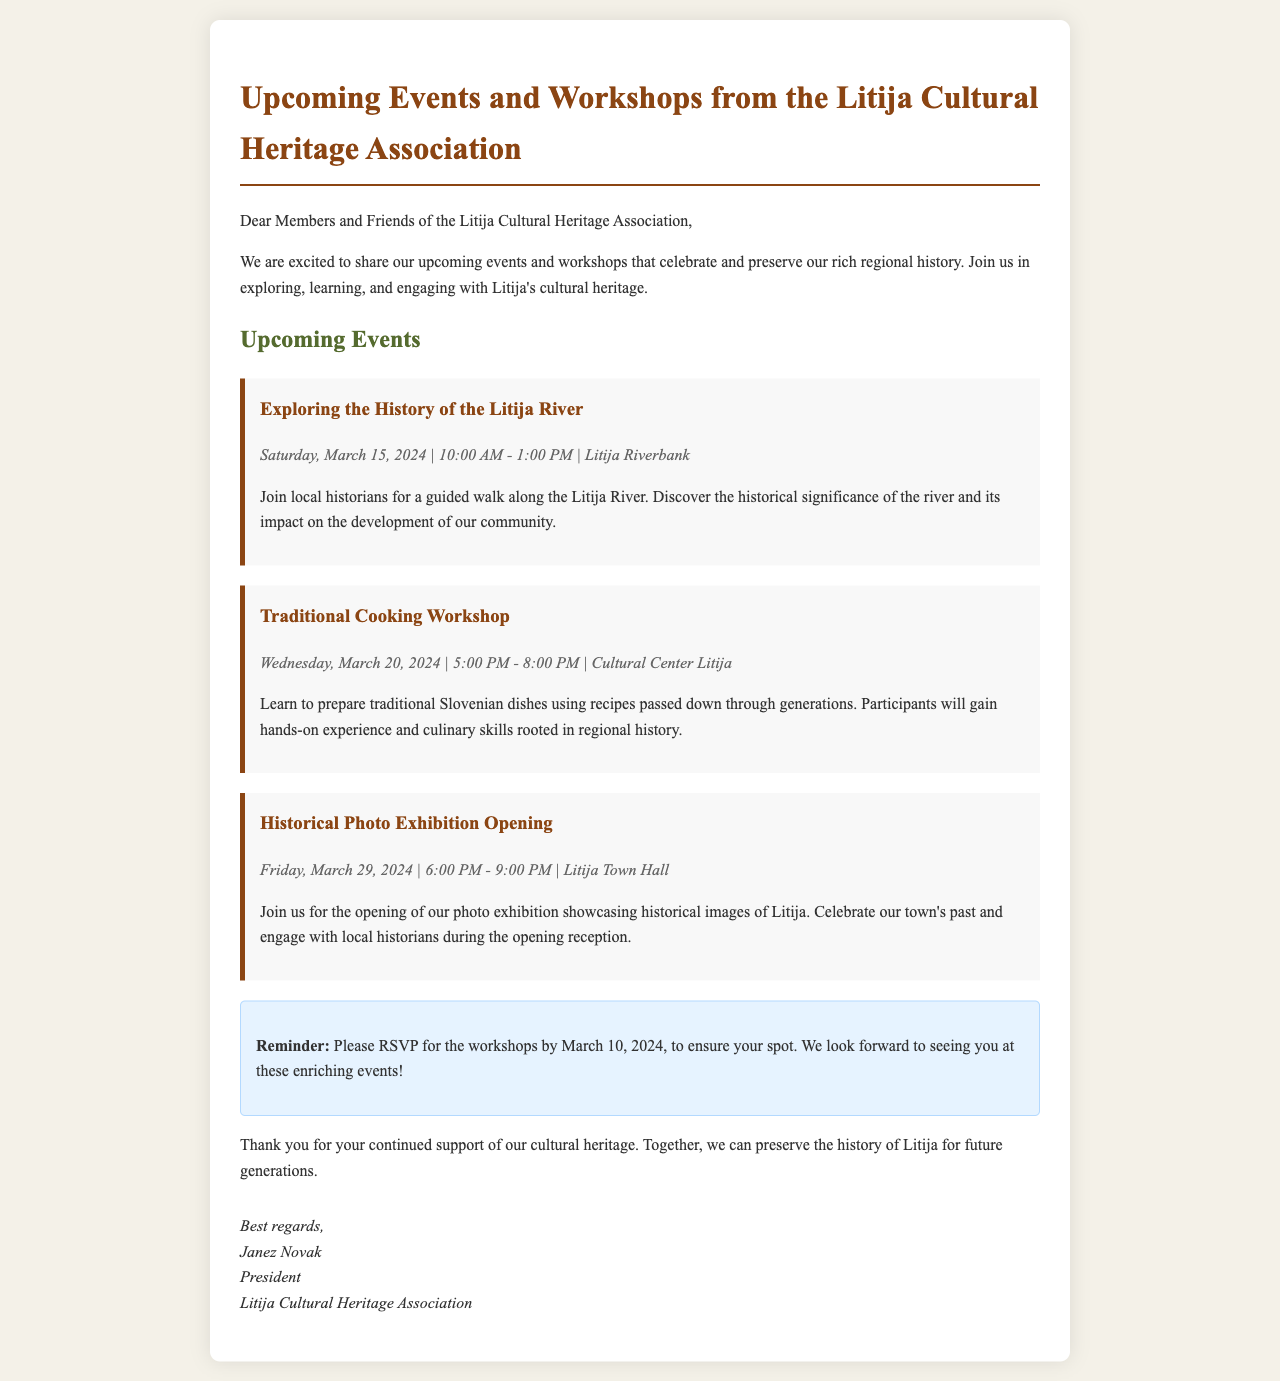what is the first event listed in the newsletter? The first event is "Exploring the History of the Litija River", which is highlighted in the document.
Answer: Exploring the History of the Litija River when is the Traditional Cooking Workshop scheduled? The date for the Traditional Cooking Workshop is provided in the document, showing it is on March 20, 2024.
Answer: March 20, 2024 where will the Historical Photo Exhibition Opening take place? The location of the Historical Photo Exhibition Opening is mentioned as Litija Town Hall in the newsletter.
Answer: Litija Town Hall what time does the Exploring the History of the Litija River event start? The starting time for the Exploring the History of the Litija River event is given in the details, which is 10:00 AM.
Answer: 10:00 AM what is required to attend the workshops? The document specifies that participants need to RSVP by a certain date to ensure their spot in the workshops.
Answer: RSVP by March 10, 2024 who is the president of the Litija Cultural Heritage Association? The document concludes with the signature identifying the president of the association.
Answer: Janez Novak how many hours is the Traditional Cooking Workshop? The event details specify the duration of the Traditional Cooking Workshop, which is three hours.
Answer: 3 hours what type of experience will participants gain at the Traditional Cooking Workshop? The document states that participants will gain hands-on experience and culinary skills, indicating the nature of the workshop.
Answer: Hands-on experience and culinary skills what is the purpose of the newsletter? The newsletter is designed to share and promote upcoming events and workshops that celebrate and preserve regional history.
Answer: To celebrate and preserve regional history 